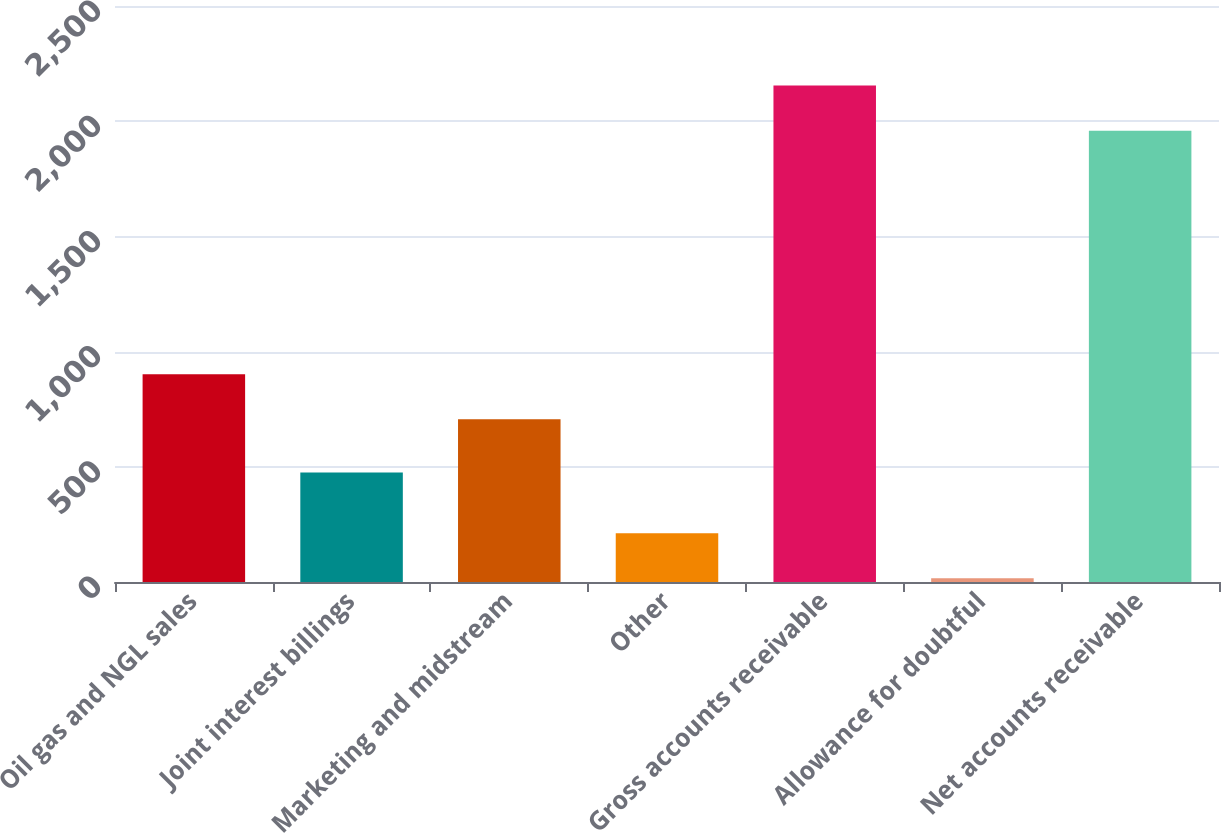Convert chart. <chart><loc_0><loc_0><loc_500><loc_500><bar_chart><fcel>Oil gas and NGL sales<fcel>Joint interest billings<fcel>Marketing and midstream<fcel>Other<fcel>Gross accounts receivable<fcel>Allowance for doubtful<fcel>Net accounts receivable<nl><fcel>901.9<fcel>475<fcel>706<fcel>211.9<fcel>2154.9<fcel>16<fcel>1959<nl></chart> 